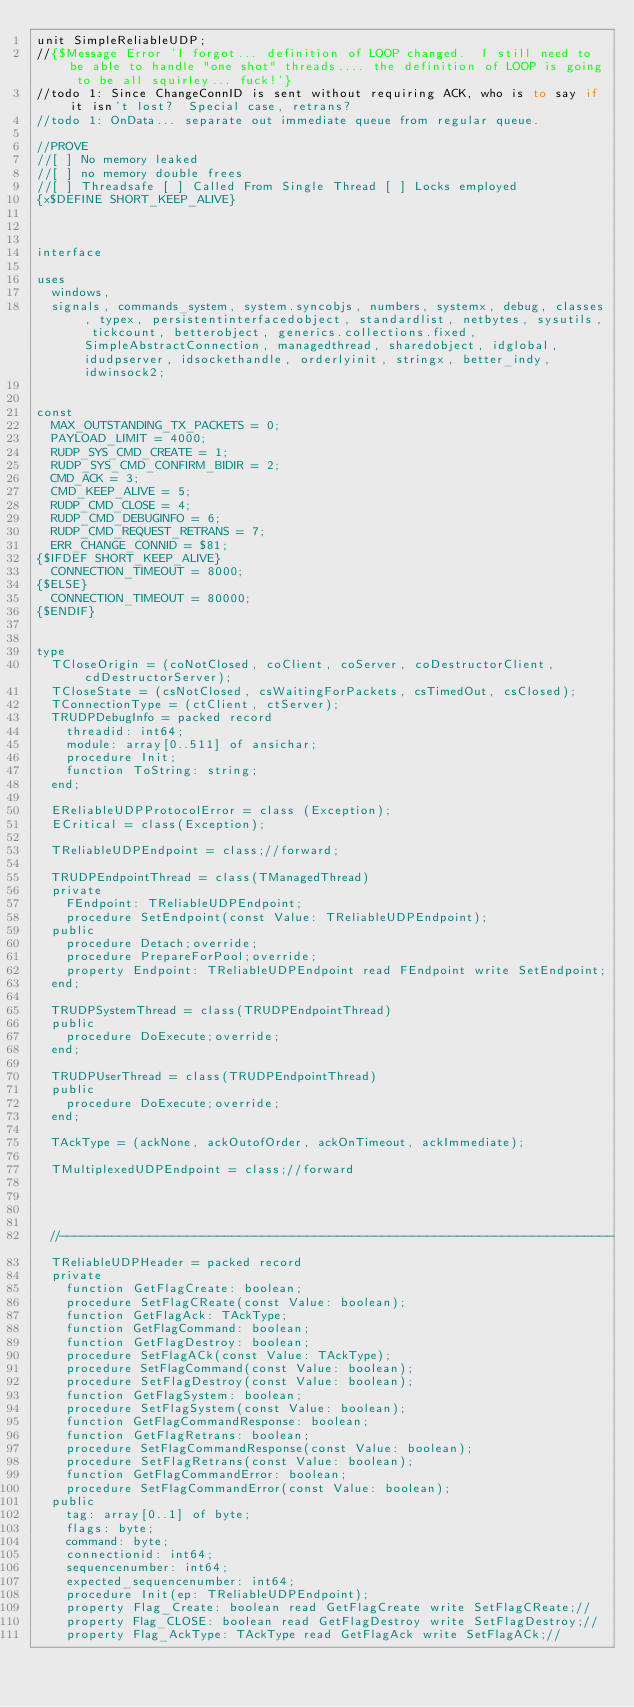<code> <loc_0><loc_0><loc_500><loc_500><_Pascal_>unit SimpleReliableUDP;
//{$Message Error 'I forgot... definition of LOOP changed.  I still need to be able to handle "one shot" threads.... the definition of LOOP is going to be all squirley... fuck!'}
//todo 1: Since ChangeConnID is sent without requiring ACK, who is to say if it isn't lost?  Special case, retrans?
//todo 1: OnData... separate out immediate queue from regular queue.

//PROVE
//[ ] No memory leaked
//[ ] no memory double frees
//[ ] Threadsafe [ ] Called From Single Thread [ ] Locks employed
{x$DEFINE SHORT_KEEP_ALIVE}



interface

uses
  windows,
  signals, commands_system, system.syncobjs, numbers, systemx, debug, classes, typex, persistentinterfacedobject, standardlist, netbytes, sysutils, tickcount, betterobject, generics.collections.fixed, SimpleAbstractConnection, managedthread, sharedobject, idglobal, idudpserver, idsockethandle, orderlyinit, stringx, better_indy, idwinsock2;


const
  MAX_OUTSTANDING_TX_PACKETS = 0;
  PAYLOAD_LIMIT = 4000;
  RUDP_SYS_CMD_CREATE = 1;
  RUDP_SYS_CMD_CONFIRM_BIDIR = 2;
  CMD_ACK = 3;
  CMD_KEEP_ALIVE = 5;
  RUDP_CMD_CLOSE = 4;
  RUDP_CMD_DEBUGINFO = 6;
  RUDP_CMD_REQUEST_RETRANS = 7;
  ERR_CHANGE_CONNID = $81;
{$IFDEF SHORT_KEEP_ALIVE}
  CONNECTION_TIMEOUT = 8000;
{$ELSE}
  CONNECTION_TIMEOUT = 80000;
{$ENDIF}


type
  TCloseOrigin = (coNotClosed, coClient, coServer, coDestructorClient, cdDestructorServer);
  TCloseState = (csNotClosed, csWaitingForPackets, csTimedOut, csClosed);
  TConnectionType = (ctClient, ctServer);
  TRUDPDebugInfo = packed record
    threadid: int64;
    module: array[0..511] of ansichar;
    procedure Init;
    function ToString: string;
  end;

  EReliableUDPProtocolError = class (Exception);
  ECritical = class(Exception);

  TReliableUDPEndpoint = class;//forward;

  TRUDPEndpointThread = class(TManagedThread)
  private
    FEndpoint: TReliableUDPEndpoint;
    procedure SetEndpoint(const Value: TReliableUDPEndpoint);
  public
    procedure Detach;override;
    procedure PrepareForPool;override;
    property Endpoint: TReliableUDPEndpoint read FEndpoint write SetEndpoint;
  end;

  TRUDPSystemThread = class(TRUDPEndpointThread)
  public
    procedure DoExecute;override;
  end;

  TRUDPUserThread = class(TRUDPEndpointThread)
  public
    procedure DoExecute;override;
  end;

  TAckType = (ackNone, ackOutofOrder, ackOnTimeout, ackImmediate);

  TMultiplexedUDPEndpoint = class;//forward




  //--------------------------------------------------------------------------
  TReliableUDPHeader = packed record
  private
    function GetFlagCreate: boolean;
    procedure SetFlagCReate(const Value: boolean);
    function GetFlagAck: TAckType;
    function GetFlagCommand: boolean;
    function GetFlagDestroy: boolean;
    procedure SetFlagACk(const Value: TAckType);
    procedure SetFlagCommand(const Value: boolean);
    procedure SetFlagDestroy(const Value: boolean);
    function GetFlagSystem: boolean;
    procedure SetFlagSystem(const Value: boolean);
    function GetFlagCommandResponse: boolean;
    function GetFlagRetrans: boolean;
    procedure SetFlagCommandResponse(const Value: boolean);
    procedure SetFlagRetrans(const Value: boolean);
    function GetFlagCommandError: boolean;
    procedure SetFlagCommandError(const Value: boolean);
  public
    tag: array[0..1] of byte;
    flags: byte;
    command: byte;
    connectionid: int64;
    sequencenumber: int64;
    expected_sequencenumber: int64;
    procedure Init(ep: TReliableUDPEndpoint);
    property Flag_Create: boolean read GetFlagCreate write SetFlagCReate;//
    property Flag_CLOSE: boolean read GetFlagDestroy write SetFlagDestroy;//
    property Flag_AckType: TAckType read GetFlagAck write SetFlagACk;//</code> 